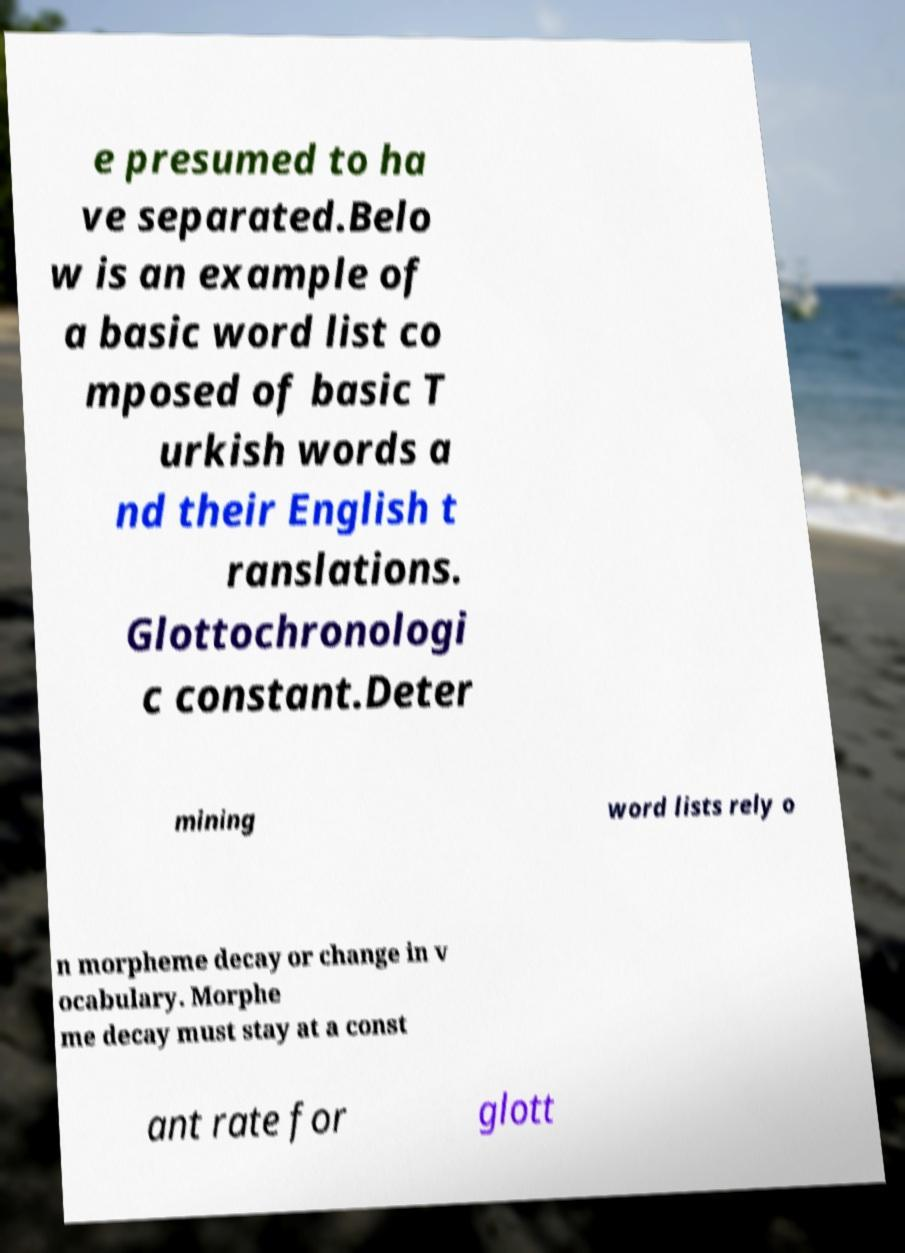What messages or text are displayed in this image? I need them in a readable, typed format. e presumed to ha ve separated.Belo w is an example of a basic word list co mposed of basic T urkish words a nd their English t ranslations. Glottochronologi c constant.Deter mining word lists rely o n morpheme decay or change in v ocabulary. Morphe me decay must stay at a const ant rate for glott 